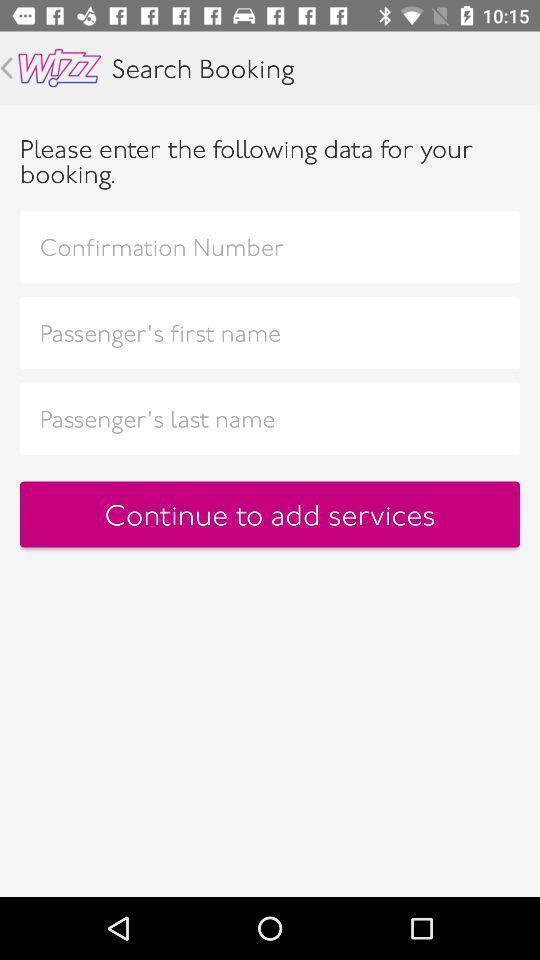Give me a summary of this screen capture. Screen displaying multiple options in bookings page. 